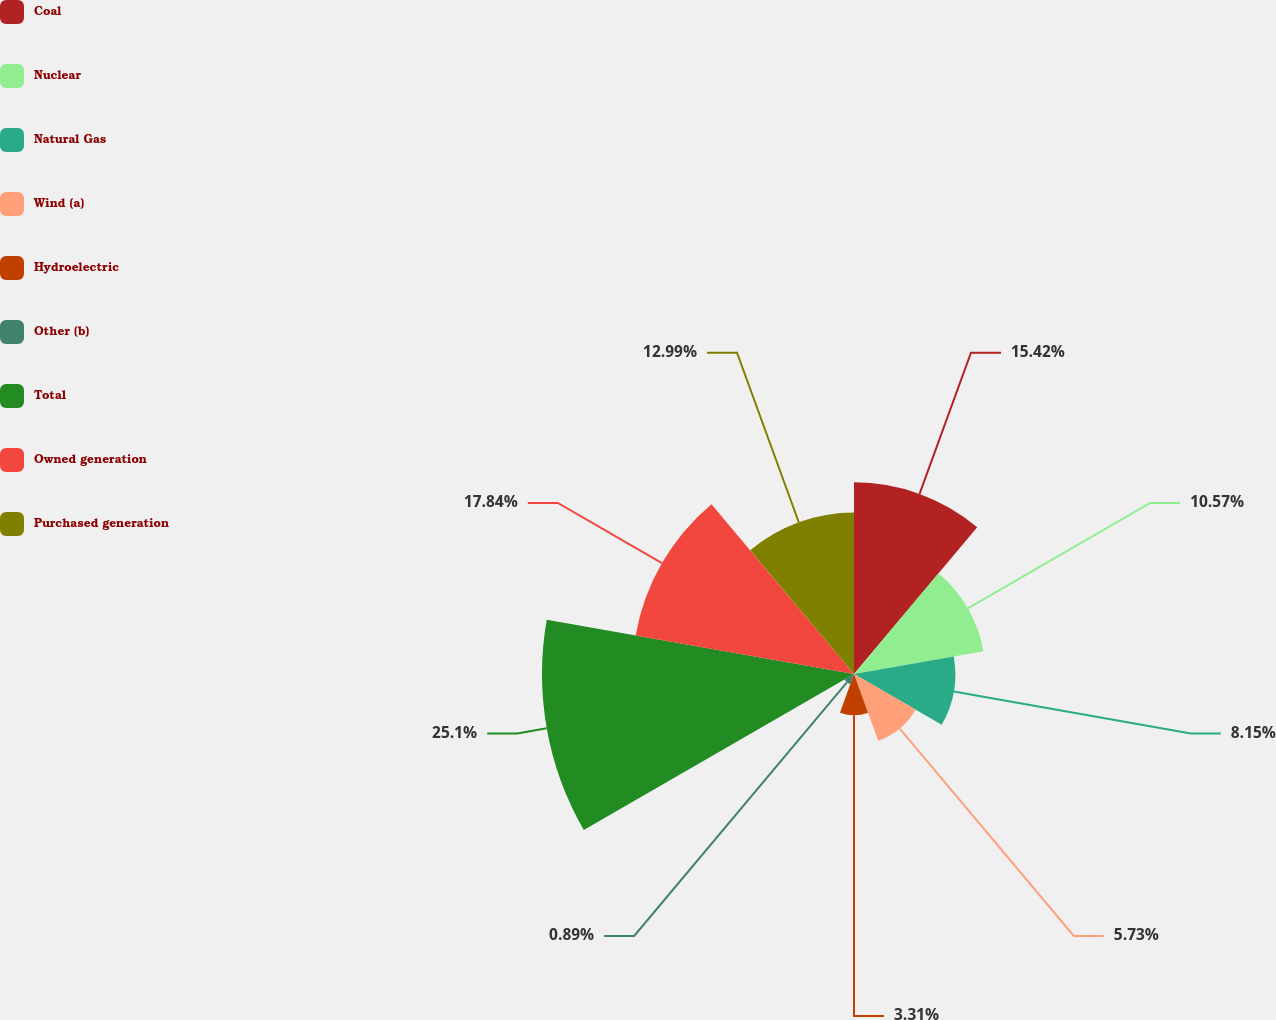<chart> <loc_0><loc_0><loc_500><loc_500><pie_chart><fcel>Coal<fcel>Nuclear<fcel>Natural Gas<fcel>Wind (a)<fcel>Hydroelectric<fcel>Other (b)<fcel>Total<fcel>Owned generation<fcel>Purchased generation<nl><fcel>15.42%<fcel>10.57%<fcel>8.15%<fcel>5.73%<fcel>3.31%<fcel>0.89%<fcel>25.1%<fcel>17.84%<fcel>12.99%<nl></chart> 